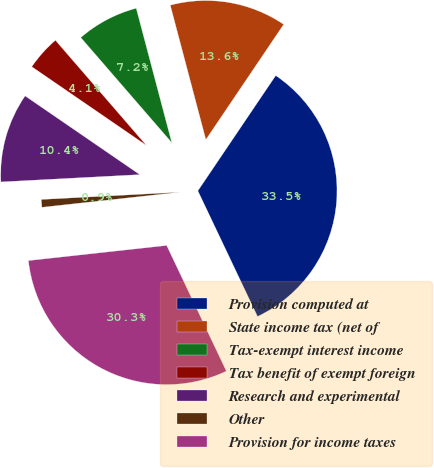Convert chart to OTSL. <chart><loc_0><loc_0><loc_500><loc_500><pie_chart><fcel>Provision computed at<fcel>State income tax (net of<fcel>Tax-exempt interest income<fcel>Tax benefit of exempt foreign<fcel>Research and experimental<fcel>Other<fcel>Provision for income taxes<nl><fcel>33.49%<fcel>13.57%<fcel>7.24%<fcel>4.07%<fcel>10.41%<fcel>0.9%<fcel>30.32%<nl></chart> 